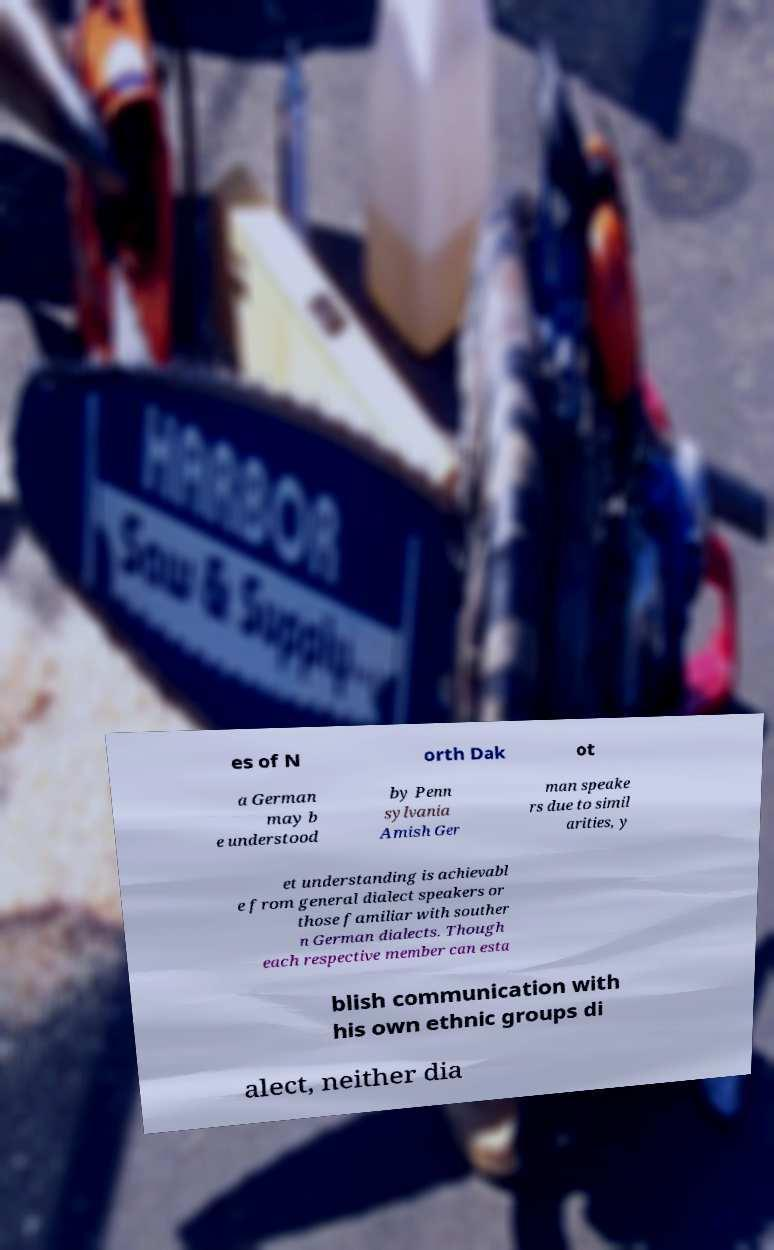Can you read and provide the text displayed in the image?This photo seems to have some interesting text. Can you extract and type it out for me? es of N orth Dak ot a German may b e understood by Penn sylvania Amish Ger man speake rs due to simil arities, y et understanding is achievabl e from general dialect speakers or those familiar with souther n German dialects. Though each respective member can esta blish communication with his own ethnic groups di alect, neither dia 